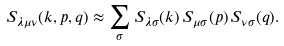<formula> <loc_0><loc_0><loc_500><loc_500>S _ { \lambda \mu \nu } ( { k } , { p } , { q } ) \approx \sum _ { \sigma } S _ { \lambda \sigma } ( k ) \, S _ { \mu \sigma } ( p ) \, S _ { \nu \sigma } ( q ) .</formula> 